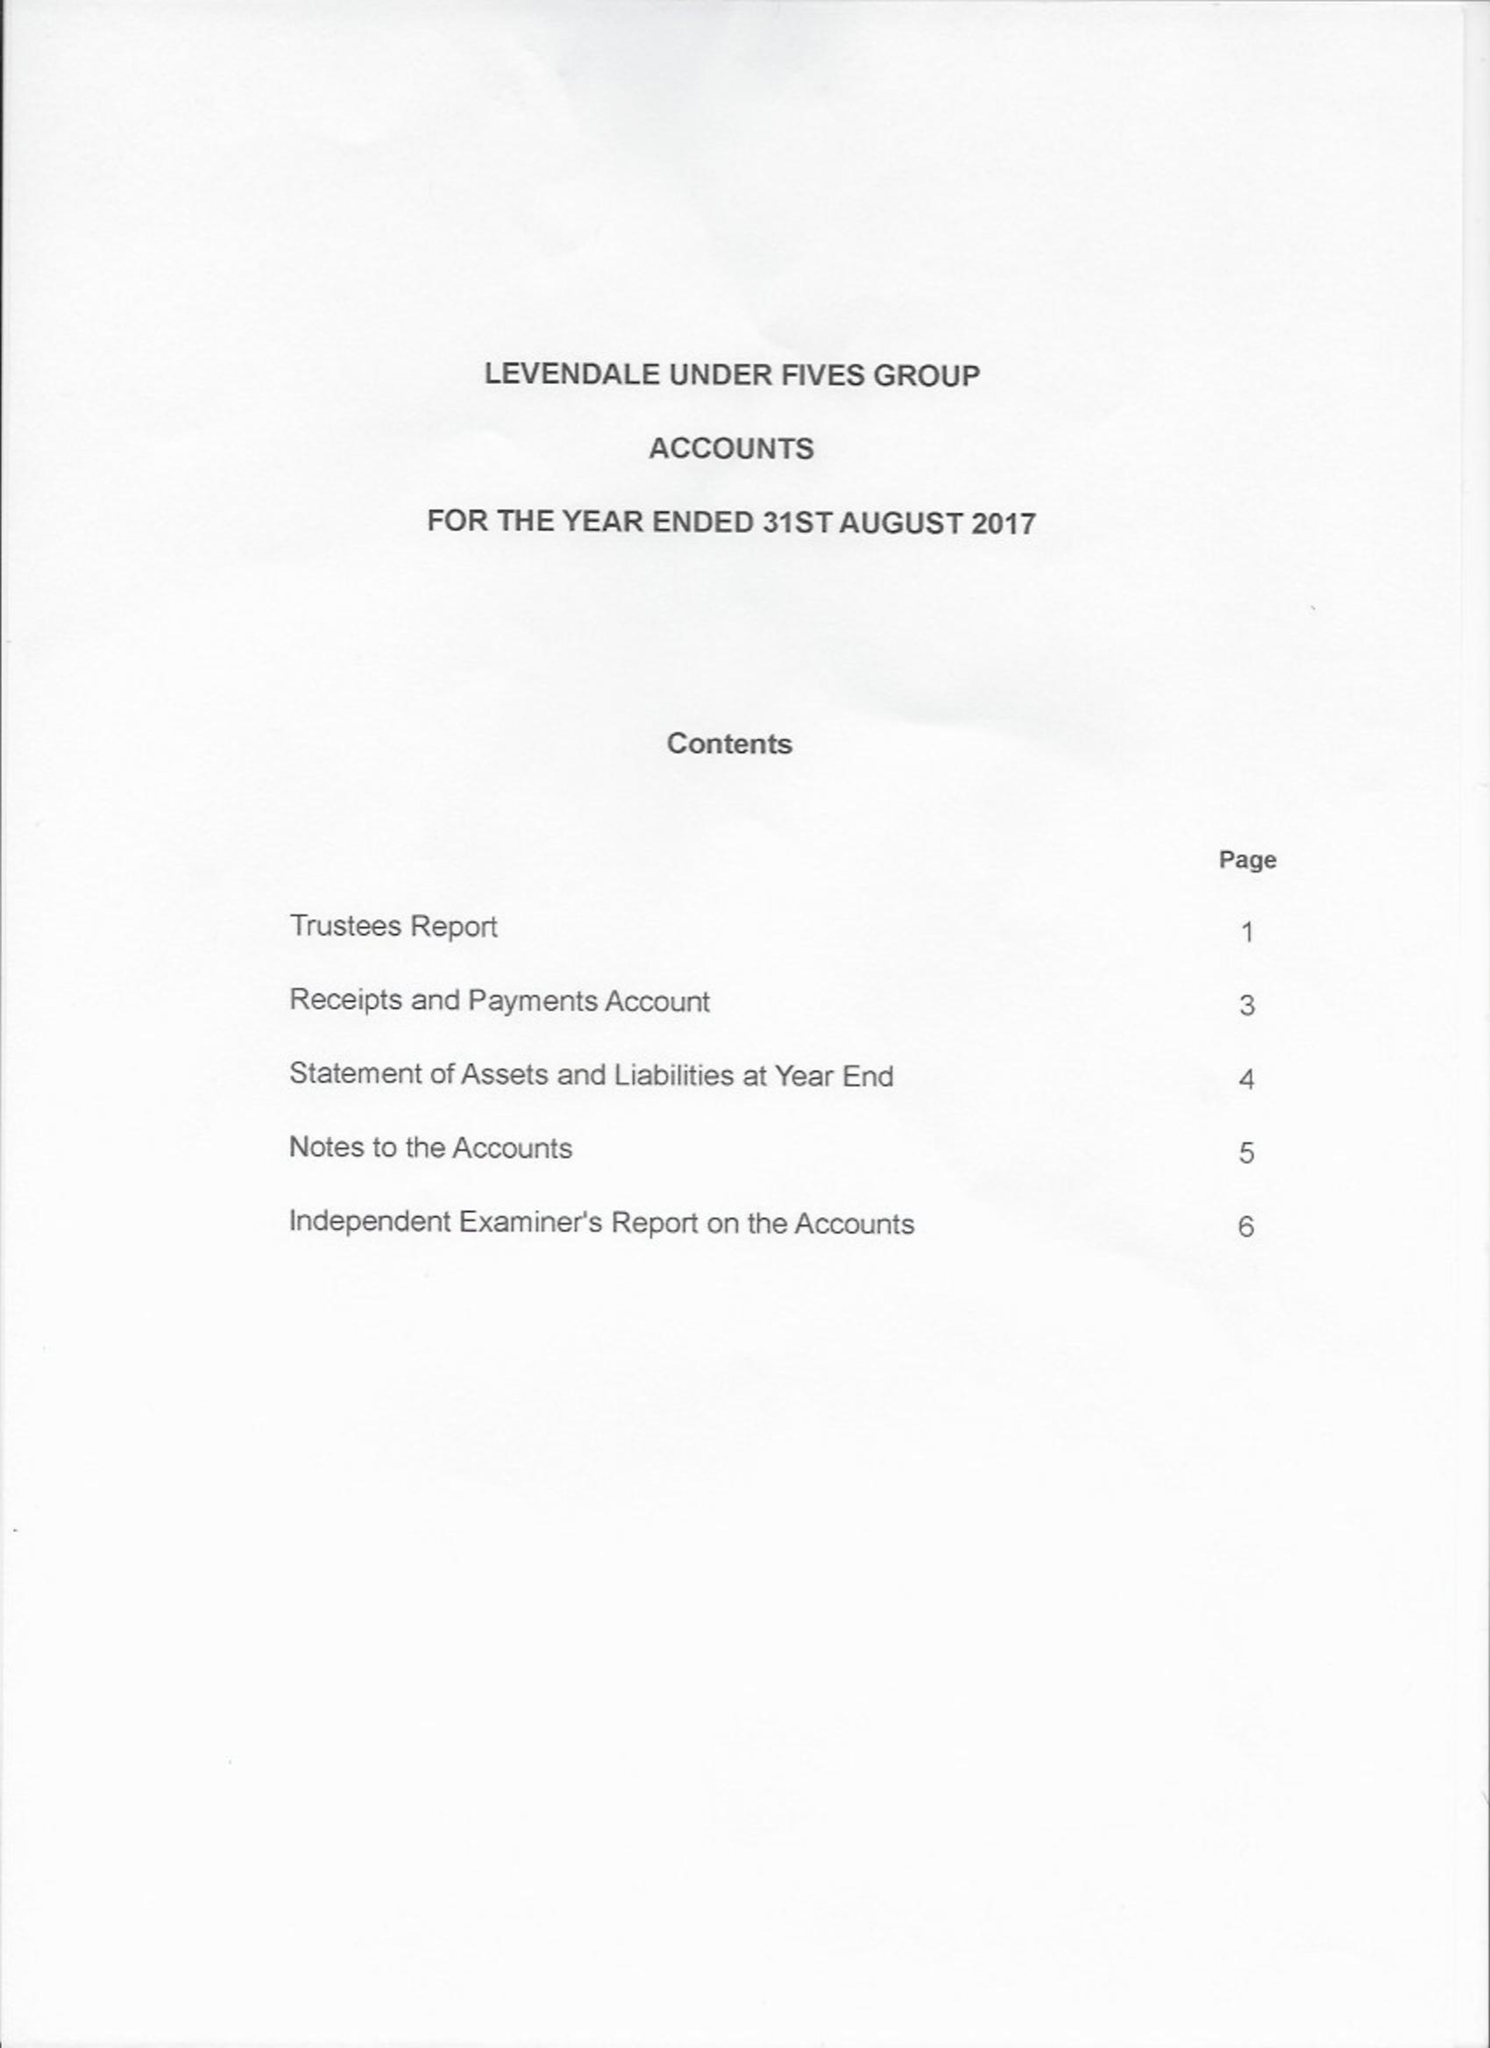What is the value for the address__postcode?
Answer the question using a single word or phrase. TS15 9RJ 